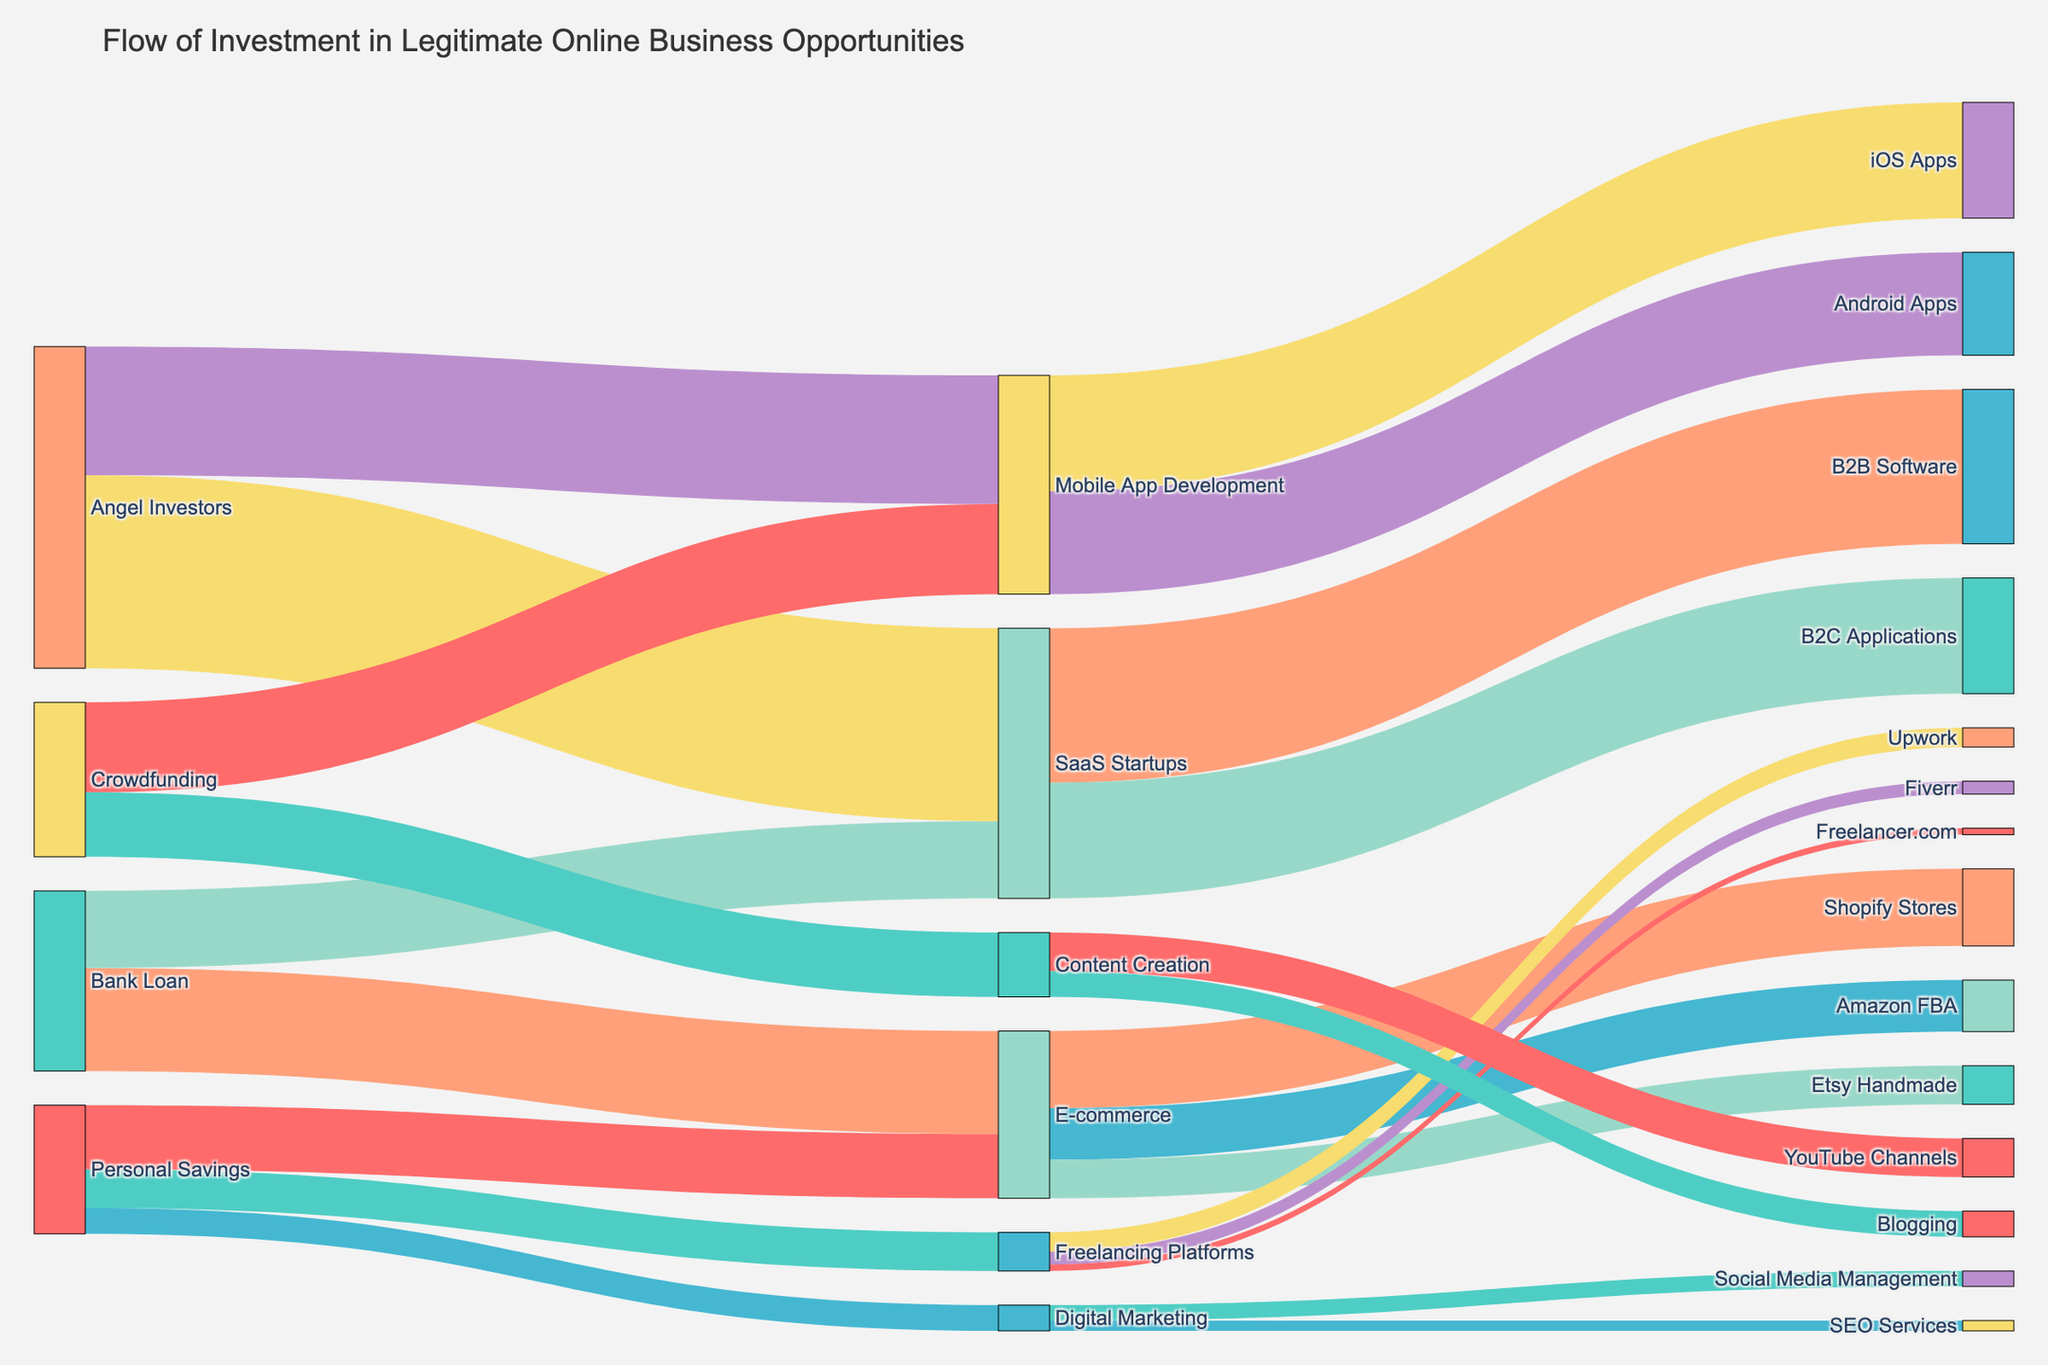What's the title of the figure? The title is typically located at the top of the figure. In this case, it reads "Flow of Investment in Legitimate Online Business Opportunities."
Answer: Flow of Investment in Legitimate Online Business Opportunities Which industry received the highest amount of investment from Angel Investors? To determine this, look at the links coming from "Angel Investors" and check the values. The target with the highest value will be the answer.
Answer: SaaS Startups What is the total investment received by E-commerce from all sources? Add the values of all links leading to "E-commerce" from different sources. From the data, it's $5000 (Personal Savings) + $8000 (Bank Loan) = $13000.
Answer: $13000 Between Freelancing Platforms and Content Creation, which received more investment from Crowdfunding? Compare the values of links from "Crowdfunding" to "Freelancing Platforms" and "Content Creation." The link to "Content Creation" is 5000, and there is no link to Freelancing Platforms.
Answer: Content Creation How much more investment did Mobile App Development receive from Angel Investors compared to Crowdfunding? Calculate the difference between the investments from Angel Investors ($10000) and Crowdfunding ($7000): $10000 - $7000 = $3000.
Answer: $3000 Among the options below E-commerce, which segment received the least funding? Look at the links branching from "E-commerce" and compare their values. "Etsy Handmade" received $3000, which is the least compared to "Amazon FBA" ($4000) and "Shopify Stores" ($6000).
Answer: Etsy Handmade What is the combined investment from Personal Savings into freelancing related fields (Freelancing Platforms and Digital Marketing)? Add together the values of investments from Personal Savings into these two fields: $3000 (Freelancing Platforms) + $2000 (Digital Marketing) = $5000.
Answer: $5000 Which funding source contributed the most overall to Online Business Opportunities? Sum the values of each funding source's contributions and compare them. Angel Investors provided a total of $15000 (SaaS Startups) + $10000 (Mobile App Development) = $25000, which is the highest.
Answer: Angel Investors Out of B2B Software and B2C Applications under SaaS Startups, which one received more funding, and by how much? Compare the investments: B2B Software ($12000) and B2C Applications ($9000). The difference is $12000 - $9000 = $3000.
Answer: B2B Software, $3000 more Which industry sector, Digital Marketing or Content Creation, received more total investment? Sum up the investments: Digital Marketing ($2000 from Personal Savings) and Content Creation ($5000 from Crowdfunding). Digital Marketing received $2000 and Content Creation received $5000.
Answer: Content Creation 